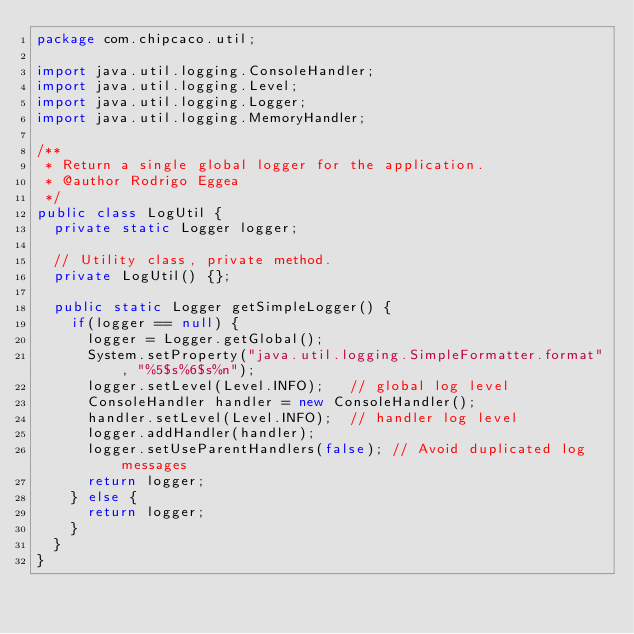Convert code to text. <code><loc_0><loc_0><loc_500><loc_500><_Java_>package com.chipcaco.util;

import java.util.logging.ConsoleHandler;
import java.util.logging.Level;
import java.util.logging.Logger;
import java.util.logging.MemoryHandler;

/**
 * Return a single global logger for the application.
 * @author Rodrigo Eggea
 */
public class LogUtil {
	private static Logger logger;
	
	// Utility class, private method.
	private LogUtil() {};
	
	public static Logger getSimpleLogger() {
		if(logger == null) {
			logger = Logger.getGlobal();
			System.setProperty("java.util.logging.SimpleFormatter.format", "%5$s%6$s%n");
			logger.setLevel(Level.INFO);   // global log level
			ConsoleHandler handler = new ConsoleHandler();
			handler.setLevel(Level.INFO);  // handler log level
			logger.addHandler(handler);
			logger.setUseParentHandlers(false); // Avoid duplicated log messages 
			return logger;
		} else {
			return logger;
		}
	}
}
</code> 